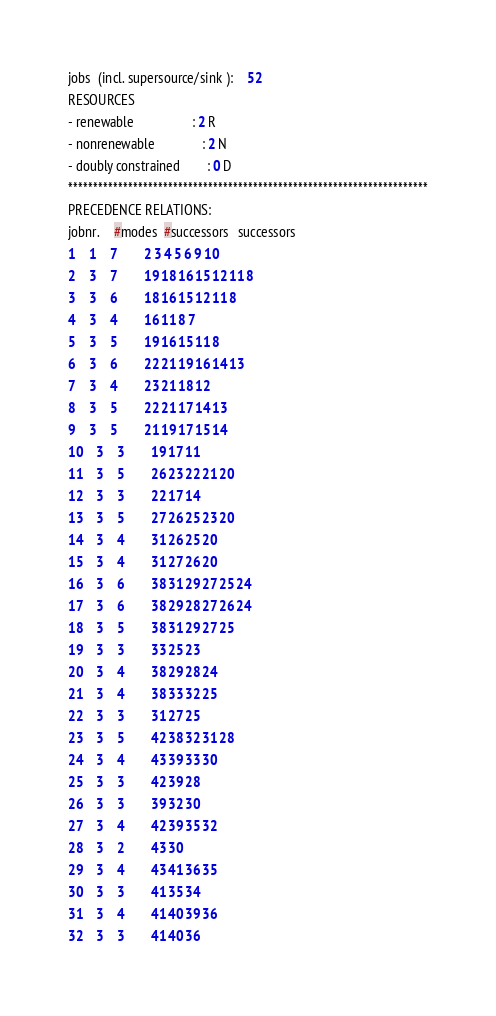Convert code to text. <code><loc_0><loc_0><loc_500><loc_500><_ObjectiveC_>jobs  (incl. supersource/sink ):	52
RESOURCES
- renewable                 : 2 R
- nonrenewable              : 2 N
- doubly constrained        : 0 D
************************************************************************
PRECEDENCE RELATIONS:
jobnr.    #modes  #successors   successors
1	1	7		2 3 4 5 6 9 10 
2	3	7		19 18 16 15 12 11 8 
3	3	6		18 16 15 12 11 8 
4	3	4		16 11 8 7 
5	3	5		19 16 15 11 8 
6	3	6		22 21 19 16 14 13 
7	3	4		23 21 18 12 
8	3	5		22 21 17 14 13 
9	3	5		21 19 17 15 14 
10	3	3		19 17 11 
11	3	5		26 23 22 21 20 
12	3	3		22 17 14 
13	3	5		27 26 25 23 20 
14	3	4		31 26 25 20 
15	3	4		31 27 26 20 
16	3	6		38 31 29 27 25 24 
17	3	6		38 29 28 27 26 24 
18	3	5		38 31 29 27 25 
19	3	3		33 25 23 
20	3	4		38 29 28 24 
21	3	4		38 33 32 25 
22	3	3		31 27 25 
23	3	5		42 38 32 31 28 
24	3	4		43 39 33 30 
25	3	3		42 39 28 
26	3	3		39 32 30 
27	3	4		42 39 35 32 
28	3	2		43 30 
29	3	4		43 41 36 35 
30	3	3		41 35 34 
31	3	4		41 40 39 36 
32	3	3		41 40 36 </code> 